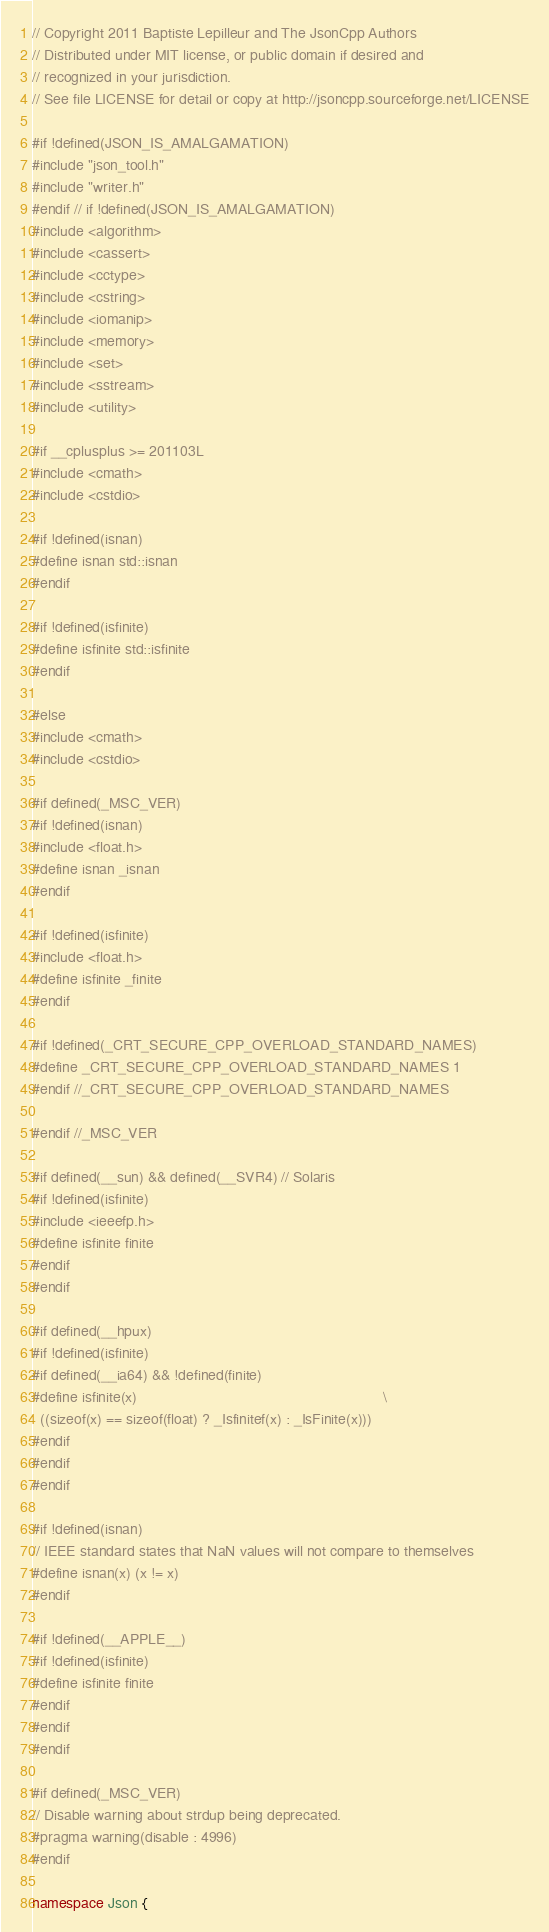Convert code to text. <code><loc_0><loc_0><loc_500><loc_500><_C++_>// Copyright 2011 Baptiste Lepilleur and The JsonCpp Authors
// Distributed under MIT license, or public domain if desired and
// recognized in your jurisdiction.
// See file LICENSE for detail or copy at http://jsoncpp.sourceforge.net/LICENSE

#if !defined(JSON_IS_AMALGAMATION)
#include "json_tool.h"
#include "writer.h"
#endif // if !defined(JSON_IS_AMALGAMATION)
#include <algorithm>
#include <cassert>
#include <cctype>
#include <cstring>
#include <iomanip>
#include <memory>
#include <set>
#include <sstream>
#include <utility>

#if __cplusplus >= 201103L
#include <cmath>
#include <cstdio>

#if !defined(isnan)
#define isnan std::isnan
#endif

#if !defined(isfinite)
#define isfinite std::isfinite
#endif

#else
#include <cmath>
#include <cstdio>

#if defined(_MSC_VER)
#if !defined(isnan)
#include <float.h>
#define isnan _isnan
#endif

#if !defined(isfinite)
#include <float.h>
#define isfinite _finite
#endif

#if !defined(_CRT_SECURE_CPP_OVERLOAD_STANDARD_NAMES)
#define _CRT_SECURE_CPP_OVERLOAD_STANDARD_NAMES 1
#endif //_CRT_SECURE_CPP_OVERLOAD_STANDARD_NAMES

#endif //_MSC_VER

#if defined(__sun) && defined(__SVR4) // Solaris
#if !defined(isfinite)
#include <ieeefp.h>
#define isfinite finite
#endif
#endif

#if defined(__hpux)
#if !defined(isfinite)
#if defined(__ia64) && !defined(finite)
#define isfinite(x)                                                            \
  ((sizeof(x) == sizeof(float) ? _Isfinitef(x) : _IsFinite(x)))
#endif
#endif
#endif

#if !defined(isnan)
// IEEE standard states that NaN values will not compare to themselves
#define isnan(x) (x != x)
#endif

#if !defined(__APPLE__)
#if !defined(isfinite)
#define isfinite finite
#endif
#endif
#endif

#if defined(_MSC_VER)
// Disable warning about strdup being deprecated.
#pragma warning(disable : 4996)
#endif

namespace Json {
</code> 